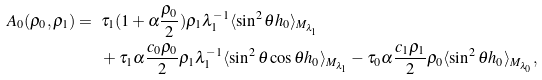Convert formula to latex. <formula><loc_0><loc_0><loc_500><loc_500>A _ { 0 } ( \rho _ { 0 } , \rho _ { 1 } ) = \ & \tau _ { 1 } ( 1 + \alpha \frac { \rho _ { 0 } } { 2 } ) \rho _ { 1 } \lambda _ { 1 } ^ { - 1 } \langle \sin ^ { 2 } \theta h _ { 0 } \rangle _ { M _ { \lambda _ { 1 } } } \\ & + \tau _ { 1 } \alpha \frac { c _ { 0 } \rho _ { 0 } } { 2 } \rho _ { 1 } \lambda _ { 1 } ^ { - 1 } \langle \sin ^ { 2 } \theta \cos \theta h _ { 0 } \rangle _ { M _ { \lambda _ { 1 } } } - \tau _ { 0 } \alpha \frac { c _ { 1 } \rho _ { 1 } } { 2 } \rho _ { 0 } \langle \sin ^ { 2 } \theta h _ { 0 } \rangle _ { M _ { \lambda _ { 0 } } } ,</formula> 